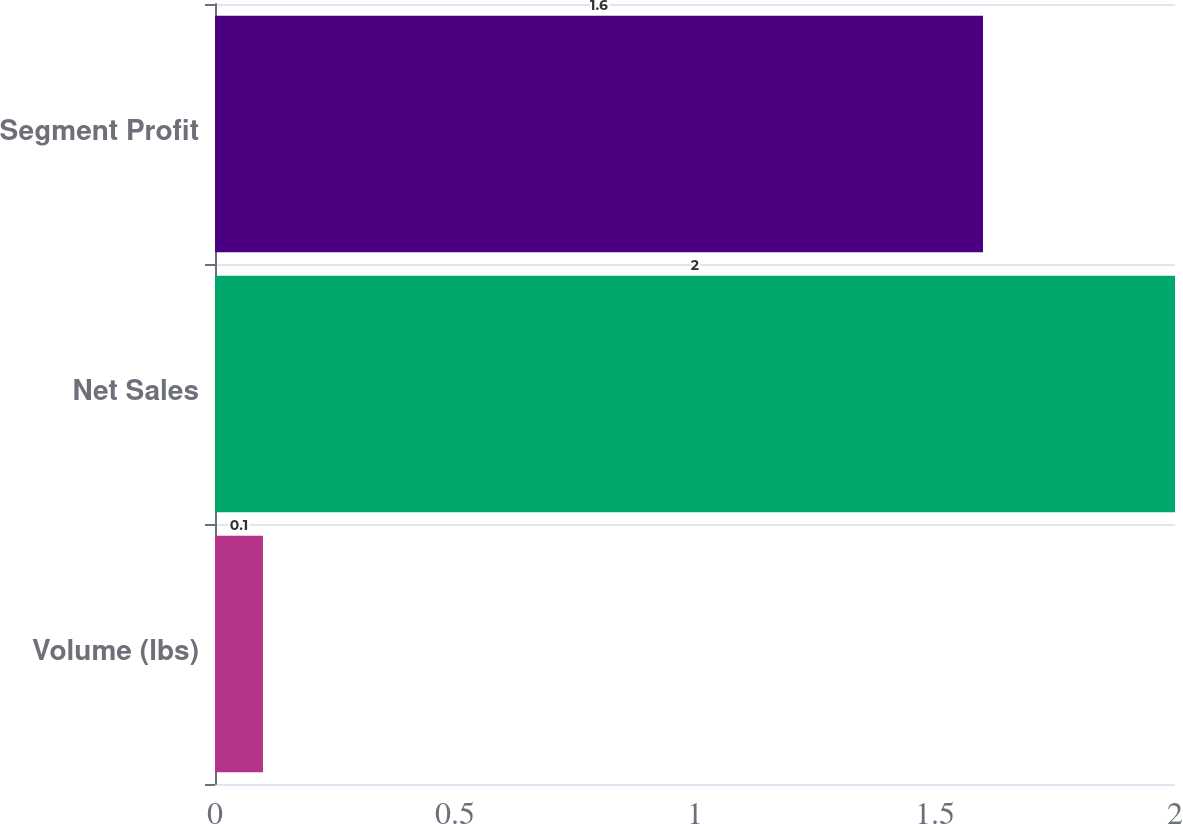Convert chart. <chart><loc_0><loc_0><loc_500><loc_500><bar_chart><fcel>Volume (lbs)<fcel>Net Sales<fcel>Segment Profit<nl><fcel>0.1<fcel>2<fcel>1.6<nl></chart> 